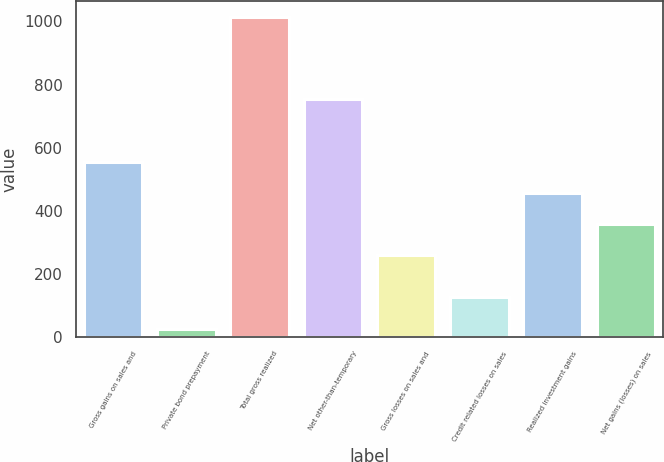Convert chart to OTSL. <chart><loc_0><loc_0><loc_500><loc_500><bar_chart><fcel>Gross gains on sales and<fcel>Private bond prepayment<fcel>Total gross realized<fcel>Net other-than-temporary<fcel>Gross losses on sales and<fcel>Credit related losses on sales<fcel>Realized investment gains<fcel>Net gains (losses) on sales<nl><fcel>555.4<fcel>27<fcel>1015<fcel>753<fcel>259<fcel>125.8<fcel>456.6<fcel>357.8<nl></chart> 